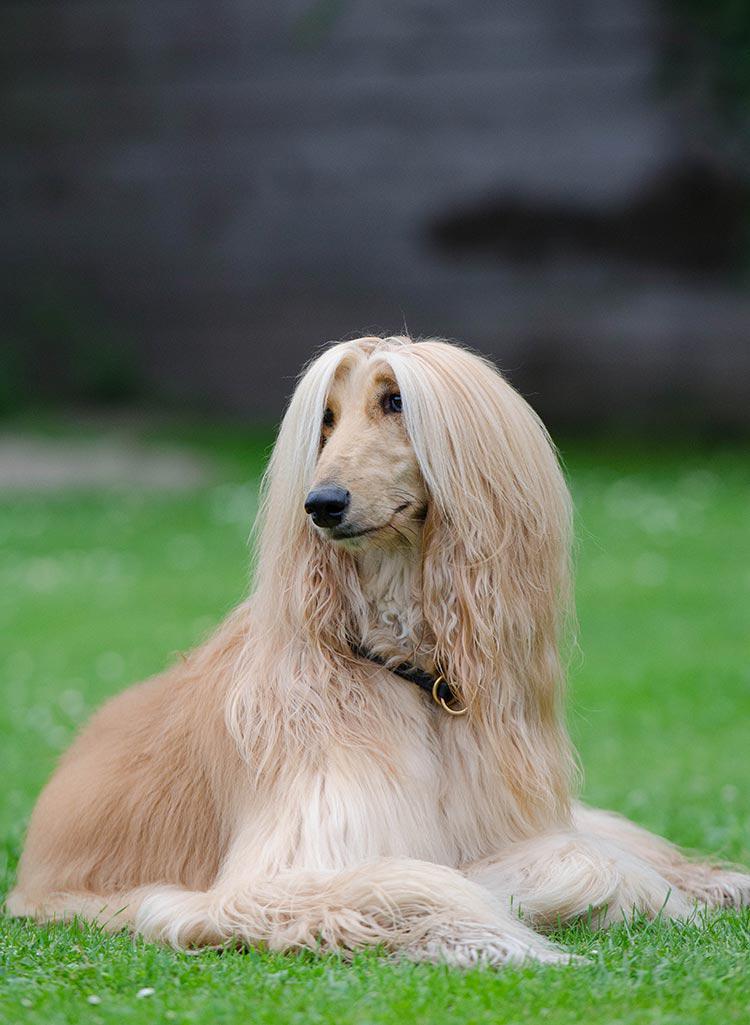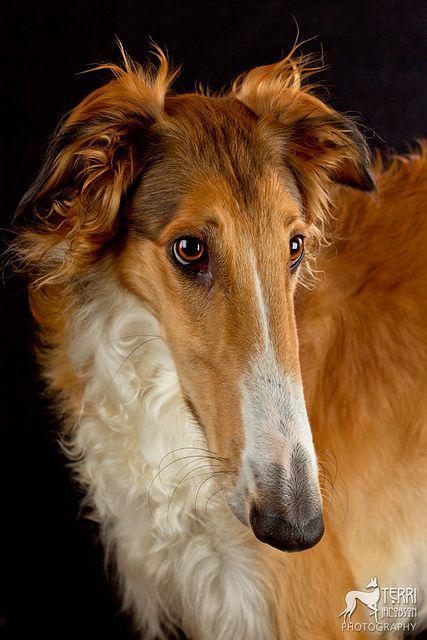The first image is the image on the left, the second image is the image on the right. For the images shown, is this caption "There is a Basset Hound in the image on the left." true? Answer yes or no. No. 